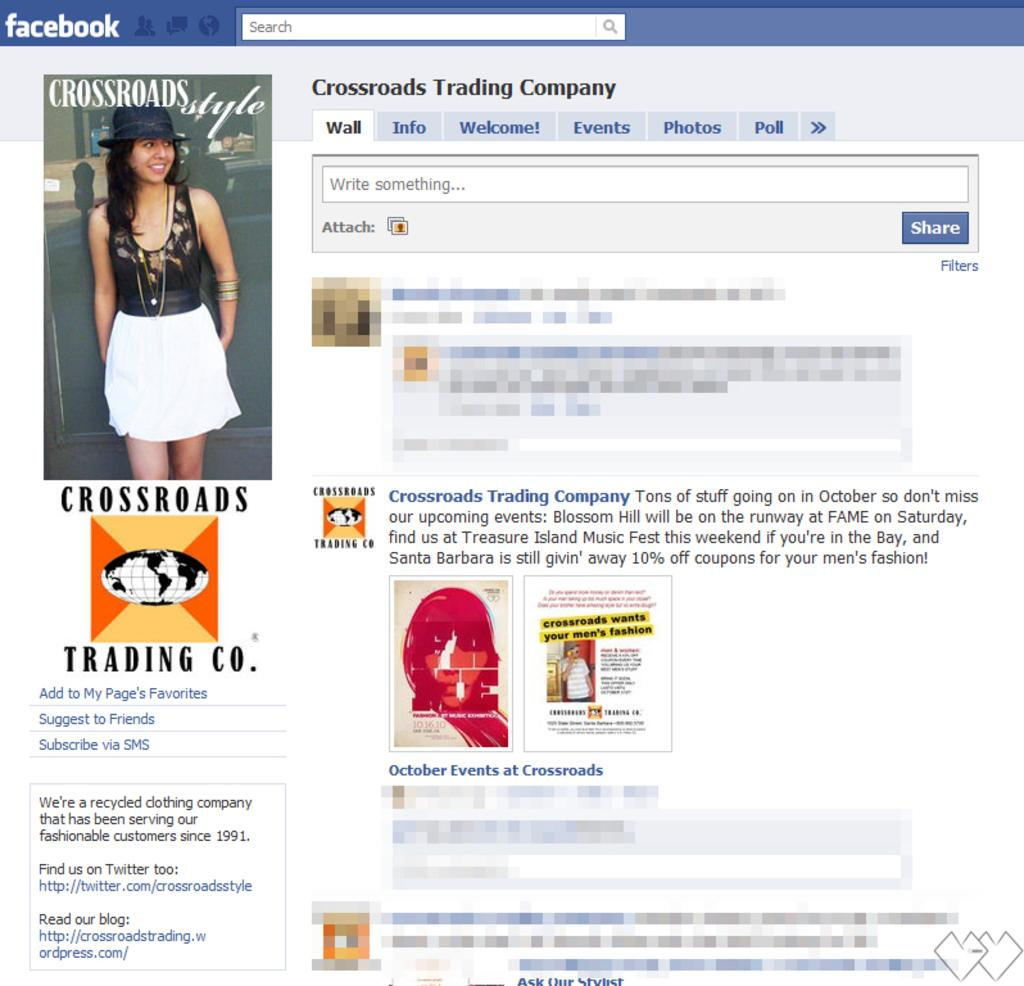What type of content is displayed in the image? The image is a web page. What type of information can be found on the web page? There is text and numbers on the web page. Are there any visual elements on the web page? Yes, there are logos and figures on the web page. How can users interact with the web page? There is a search bar on the web page for users to input search queries. What type of pen is used to write the fiction on the web page? There is no fiction present on the web page, and therefore no pen is used to write it. 